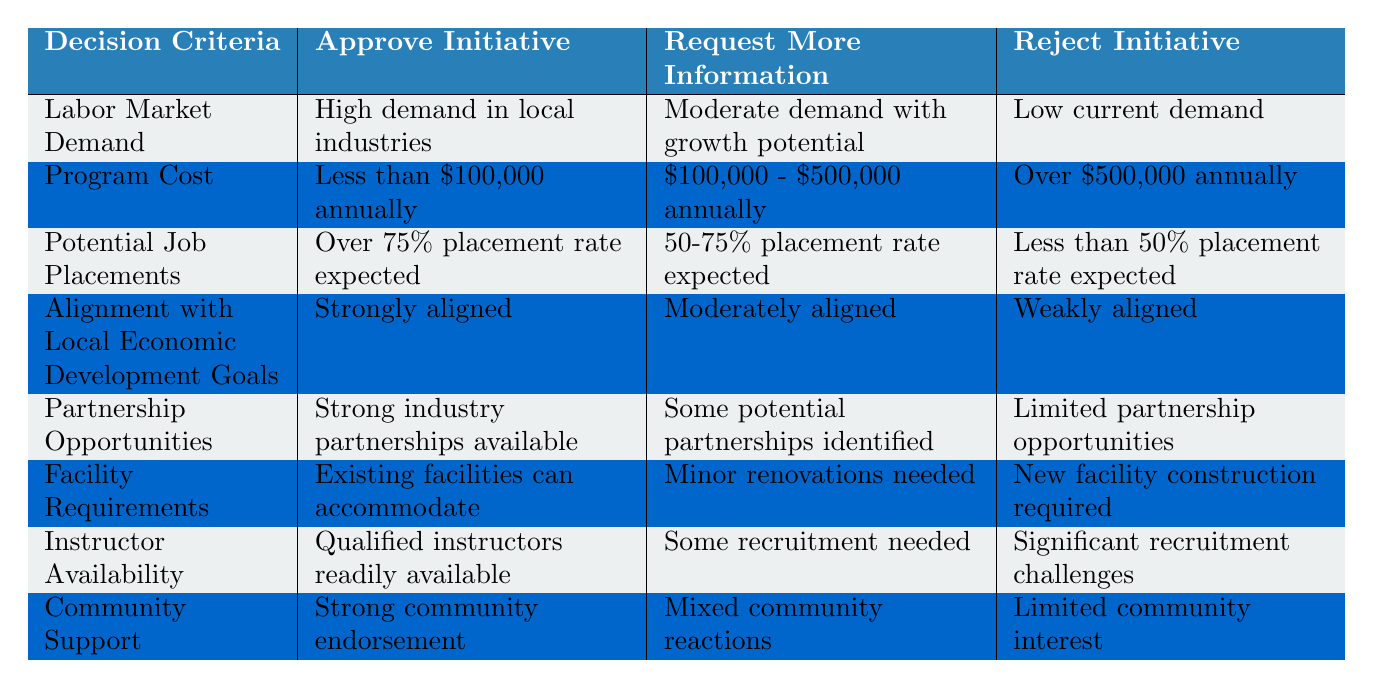What is the criterion that has "Strongly aligned" as an option for approving an initiative? The criterion that has "Strongly aligned" as an option is "Alignment with Local Economic Development Goals." This can be found directly in the table under the column for "Approve Initiative."
Answer: Alignment with Local Economic Development Goals How many decision criteria offer options for "Over 75% placement rate expected"? The table shows that "Potential Job Placements" is the only criterion with the option "Over 75% placement rate expected." This criterion exists only in one row of the table under the "Approve Initiative" column.
Answer: 1 Is it true that a program with "Significant recruitment challenges" would be rejected? Yes, it is true. The table indicates that "Instructor Availability" with "Significant recruitment challenges" falls under the "Reject Initiative" column. This means such a program is likely to be rejected based on this criterion.
Answer: Yes What is the average cost range for approving initiatives based on the table? To determine the average cost range for approving initiatives, we see that the only approval criterion listed is "Less than $100,000 annually." Since this is the only relevant option for approval, the average cost range is simply this single value, as there are no other values to calculate an average from.
Answer: Less than $100,000 annually How would you classify community support if it is "Mixed community reactions"? "Mixed community reactions" falls under the "Request More Information" category as per the table. This implies that when community support is not strong, it may need further evaluation before deciding on approval.
Answer: Request More Information Which criterion has the most severe rejection condition and what is that condition? The criterion "Instructor Availability" has the most severe rejection condition, which is "Significant recruitment challenges." This is indicated in the table where it corresponds to the "Reject Initiative" column.
Answer: Significant recruitment challenges Is "High demand in local industries" a sufficient criterion alone for approving initiatives? Yes, based on the table, "High demand in local industries" is classified under the "Approve Initiative," indicating that if local industries exhibit high demand, it can be a sufficient criterion for approval.
Answer: Yes What combinations of criteria would lead to a rejection of an initiative? An initiative could be rejected if it is classified as having "Low current demand" for Labor Market Demand, "Over $500,000 annually" for Program Cost, "Less than 50% placement rate expected" for Potential Job Placements, or "Weakly aligned" for Alignment with Local Economic Development Goals, among others. Each of these criteria corresponds to the "Reject Initiative" category.
Answer: Various combinations based on rejection criteria 